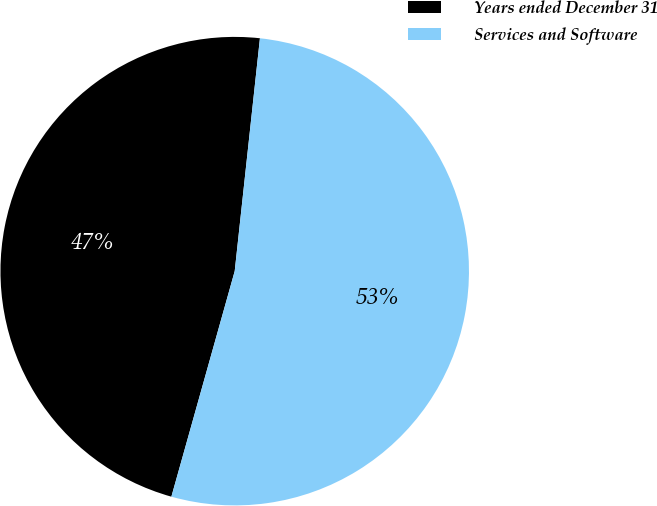Convert chart. <chart><loc_0><loc_0><loc_500><loc_500><pie_chart><fcel>Years ended December 31<fcel>Services and Software<nl><fcel>47.36%<fcel>52.64%<nl></chart> 